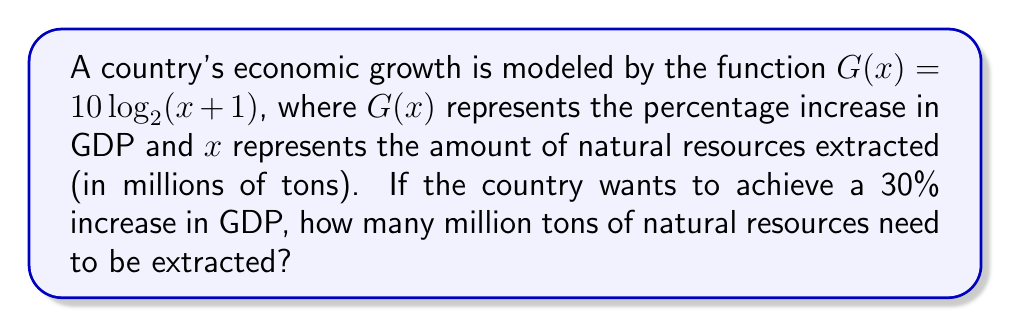Help me with this question. To solve this problem, we need to follow these steps:

1) We're given that $G(x) = 10 \log_2(x + 1)$, and we want to find $x$ when $G(x) = 30$.

2) Let's substitute these values into the equation:
   $30 = 10 \log_2(x + 1)$

3) Divide both sides by 10:
   $3 = \log_2(x + 1)$

4) To solve for $x$, we need to apply the inverse function of $\log_2$, which is $2^x$:
   $2^3 = x + 1$

5) Calculate $2^3$:
   $8 = x + 1$

6) Subtract 1 from both sides:
   $7 = x$

Therefore, 7 million tons of natural resources need to be extracted to achieve a 30% increase in GDP according to this model.
Answer: 7 million tons 